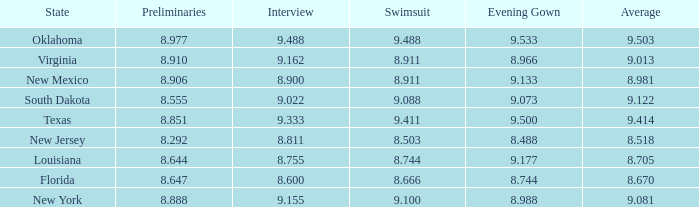 what's the evening gown where state is south dakota 9.073. 